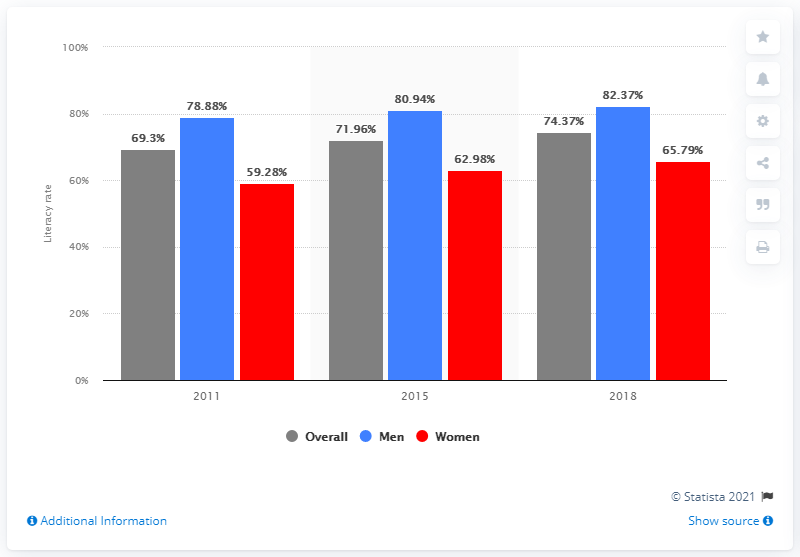Draw attention to some important aspects in this diagram. The average of the red bars in the chart is 62.68. In 2015, the literacy rate among men experienced the largest increase. 